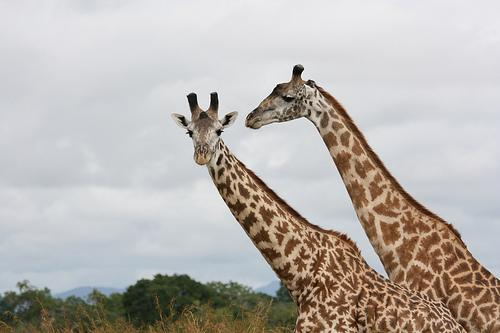Identify the objects or entities in the image that are interacting with each other. Two giraffes are interacting with one another, while also engaging with the surrounding natural environment. Based on the information provided, please analyze the possible interactions between the giraffes and their environment. The giraffes might be interacting with their environment by grazing on the nearby trees, or simply enjoying each other's company while inhabiting a harmonious natural space. Please provide a simple description of the overall scene in the image. The image features two giraffes with brown spots and long necks standing outside, with green trees, mountains, and a blue sky with clouds in the background. What is the primary focus of the image? Describe its appearance. The primary focus is on the two tall giraffes with long necks, having tan and brown spotted fur, standing outside. What emotions or feelings might be evoked by this scene? The scene may evoke feelings of serenity, joy, or fascination due to the presence of the majestic giraffes and the natural, peaceful background. In this picture, how many giraffes can you identify and what color are their spots? There are two giraffes in the image, and their spots are brown and tan. Describe the sky in the image, including its color and the presence of any other elements. The sky is blue with numerous white clouds scattered throughout it. Enumerate the elements present in the background of the image In the background, there are green trees, mountains with various peaks, and a blue sky filled with white clouds. Please provide an assessment of the quality of this image based on the clarity of the objects and the overall composition. The image quality appears to be quite high, as the objects are clearly visible and the overall composition is well-organized and visually appealing. How many mountain peaks can you count in this image, and what is their position in relation to the trees? There are ten mountain peaks in the image, and they are located behind the trees. 